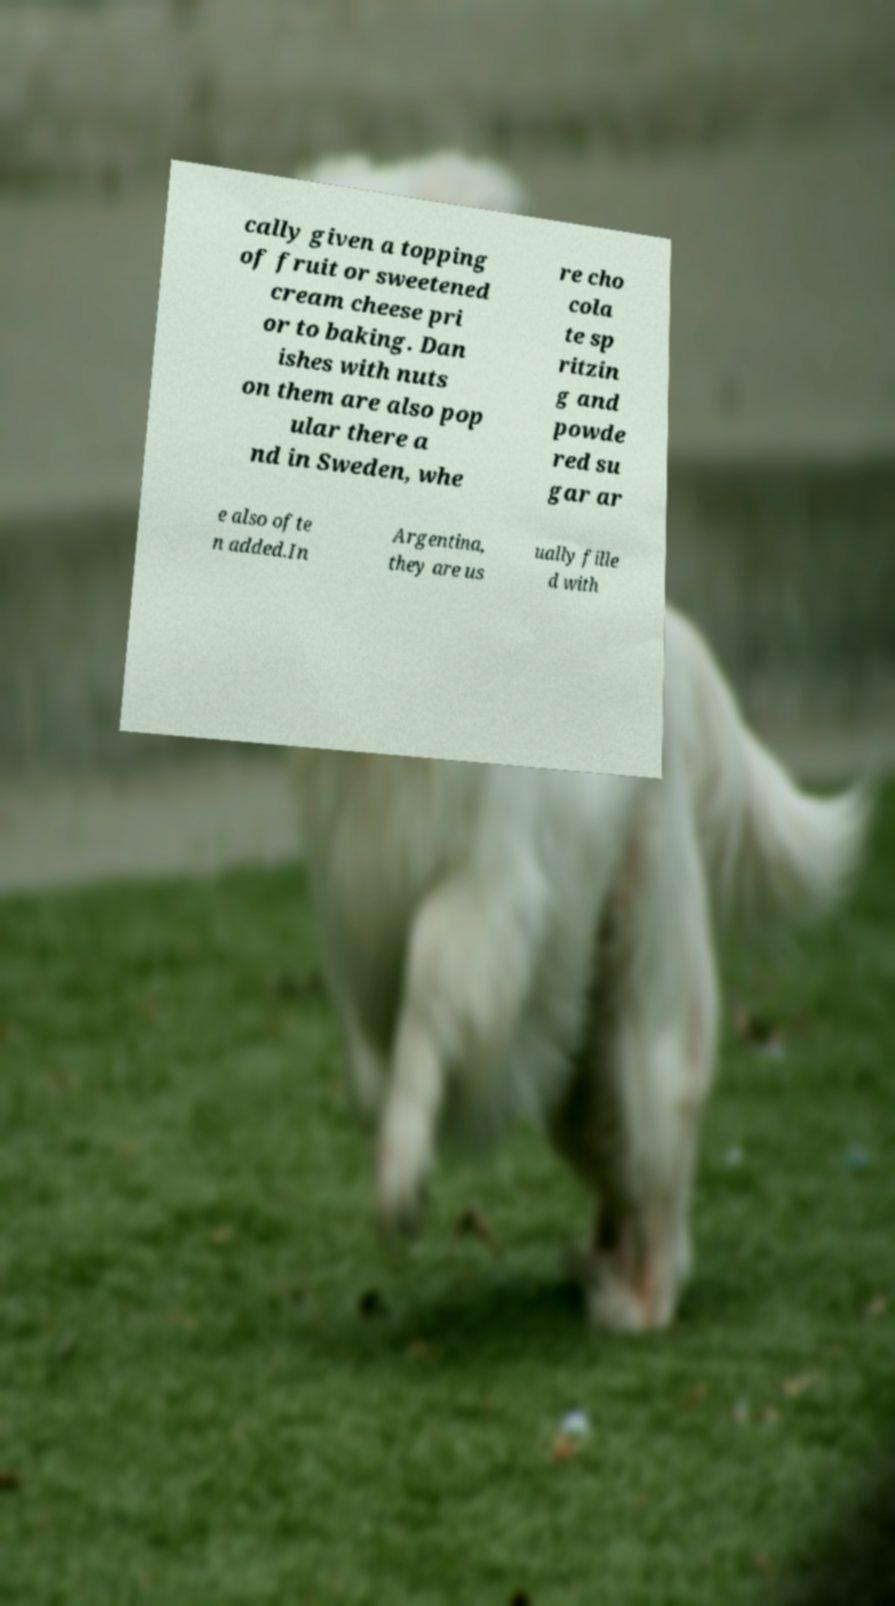Can you accurately transcribe the text from the provided image for me? cally given a topping of fruit or sweetened cream cheese pri or to baking. Dan ishes with nuts on them are also pop ular there a nd in Sweden, whe re cho cola te sp ritzin g and powde red su gar ar e also ofte n added.In Argentina, they are us ually fille d with 